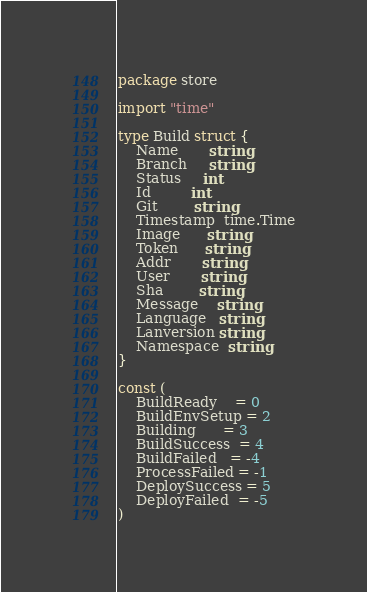<code> <loc_0><loc_0><loc_500><loc_500><_Go_>package store

import "time"

type Build struct {
	Name       string
	Branch     string
	Status     int
	Id         int
	Git        string
	Timestamp  time.Time
	Image      string
	Token      string
	Addr       string
	User       string
	Sha        string
	Message    string
	Language   string
	Lanversion string
	Namespace  string
}

const (
	BuildReady    = 0
	BuildEnvSetup = 2
	Building      = 3
	BuildSuccess  = 4
	BuildFailed   = -4
	ProcessFailed = -1
	DeploySuccess = 5
	DeployFailed  = -5
)
</code> 